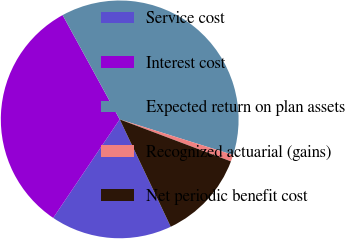<chart> <loc_0><loc_0><loc_500><loc_500><pie_chart><fcel>Service cost<fcel>Interest cost<fcel>Expected return on plan assets<fcel>Recognized actuarial (gains)<fcel>Net periodic benefit cost<nl><fcel>16.51%<fcel>32.58%<fcel>37.81%<fcel>0.91%<fcel>12.19%<nl></chart> 